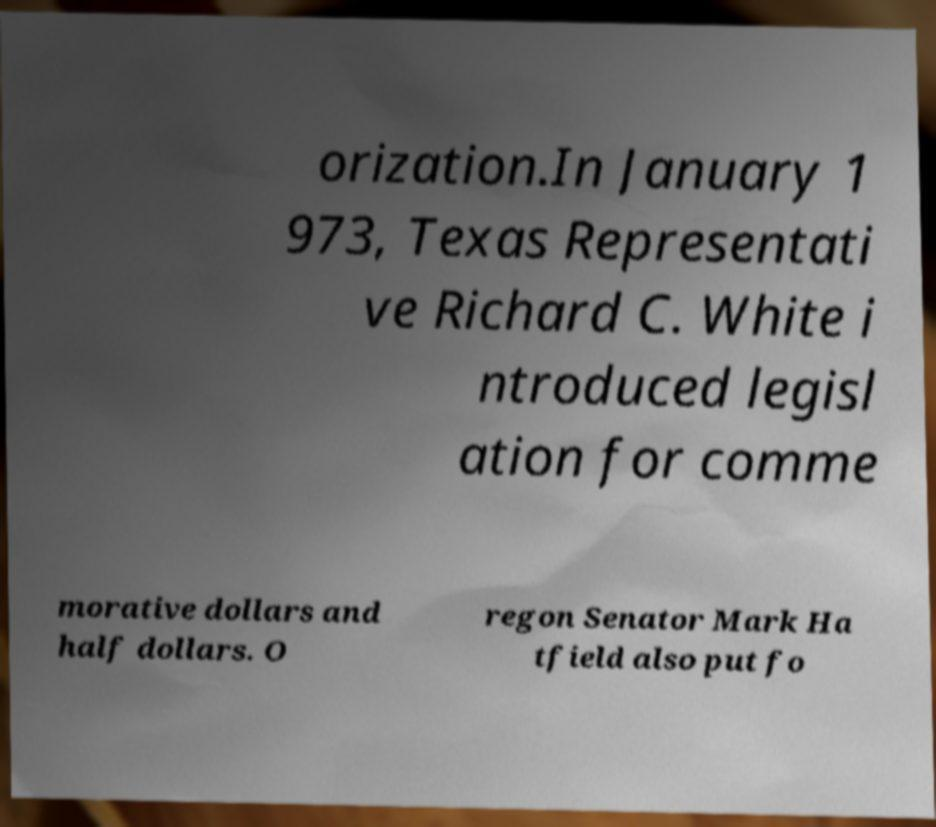Could you extract and type out the text from this image? orization.In January 1 973, Texas Representati ve Richard C. White i ntroduced legisl ation for comme morative dollars and half dollars. O regon Senator Mark Ha tfield also put fo 